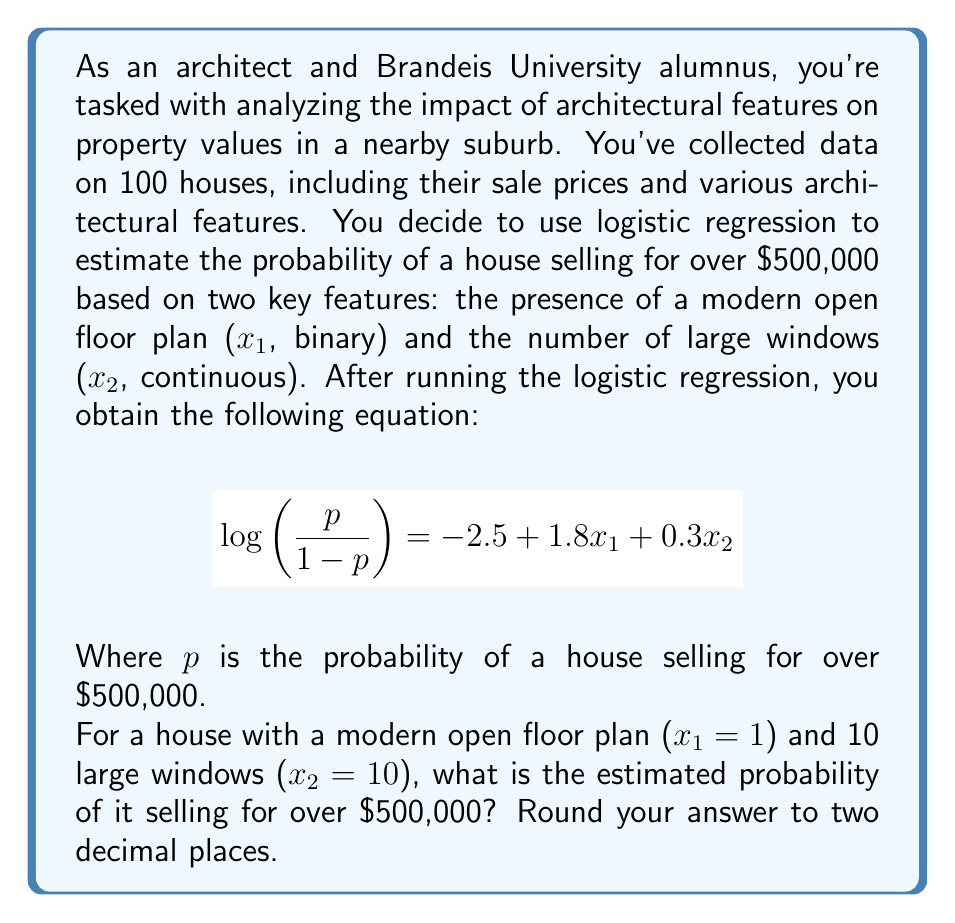Teach me how to tackle this problem. Let's approach this step-by-step:

1) We start with the logistic regression equation:
   $$\log\left(\frac{p}{1-p}\right) = -2.5 + 1.8x_1 + 0.3x_2$$

2) We know that x₁ = 1 (presence of modern open floor plan) and x₂ = 10 (number of large windows). Let's substitute these values:
   $$\log\left(\frac{p}{1-p}\right) = -2.5 + 1.8(1) + 0.3(10)$$

3) Simplify:
   $$\log\left(\frac{p}{1-p}\right) = -2.5 + 1.8 + 3 = 2.3$$

4) Now we have:
   $$\frac{p}{1-p} = e^{2.3}$$

5) To solve for p, we can use the following steps:
   $$p = \frac{e^{2.3}}{1 + e^{2.3}}$$

6) Calculate $e^{2.3}$:
   $$e^{2.3} \approx 9.9742$$

7) Substitute this value:
   $$p = \frac{9.9742}{1 + 9.9742} = \frac{9.9742}{10.9742}$$

8) Calculate and round to two decimal places:
   $$p \approx 0.91 \text{ or } 91\%$$

Therefore, the estimated probability of this house selling for over $500,000 is 0.91 or 91%.
Answer: 0.91 